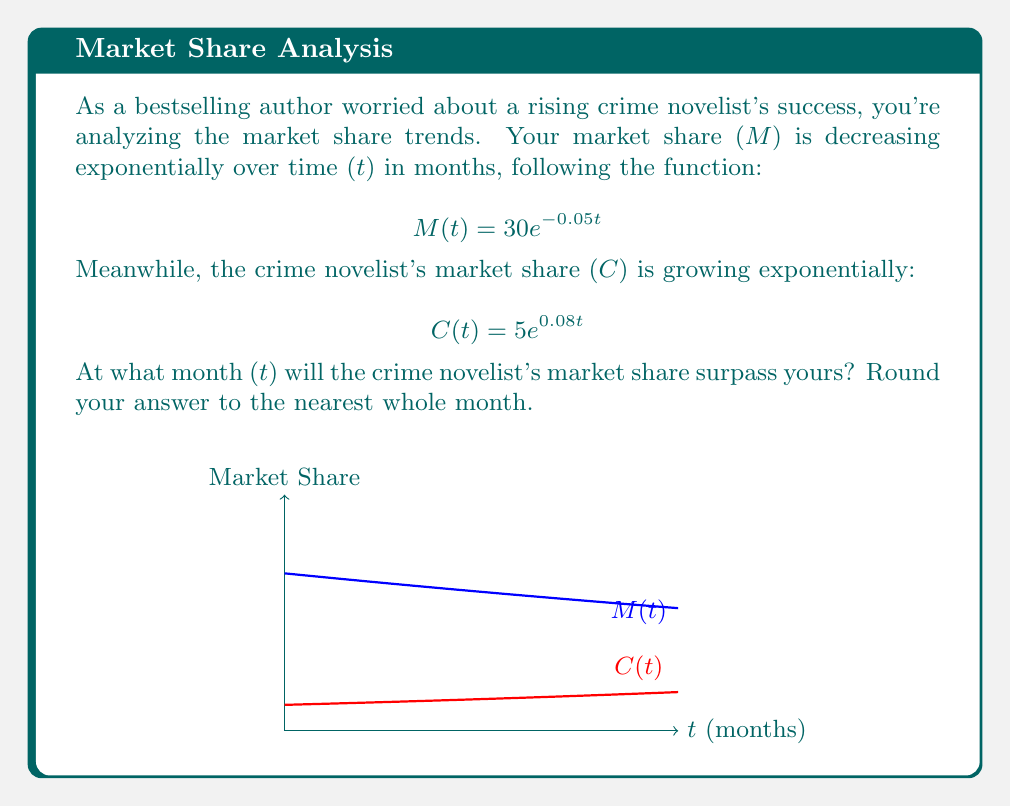Help me with this question. To find when the crime novelist's market share surpasses yours, we need to set the two functions equal and solve for t:

1) Set the equations equal:
   $$30e^{-0.05t} = 5e^{0.08t}$$

2) Take the natural log of both sides:
   $$\ln(30e^{-0.05t}) = \ln(5e^{0.08t})$$

3) Use the properties of logarithms:
   $$\ln(30) + \ln(e^{-0.05t}) = \ln(5) + \ln(e^{0.08t})$$
   $$\ln(30) - 0.05t = \ln(5) + 0.08t$$

4) Solve for t:
   $$\ln(30) - \ln(5) = 0.08t + 0.05t$$
   $$\ln(6) = 0.13t$$
   $$t = \frac{\ln(6)}{0.13}$$

5) Calculate and round to the nearest whole month:
   $$t \approx 13.76 \approx 14$$

Therefore, the crime novelist's market share will surpass yours in the 14th month.
Answer: 14 months 